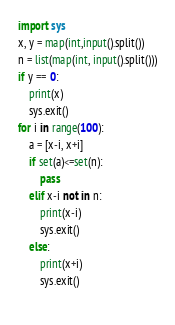<code> <loc_0><loc_0><loc_500><loc_500><_Python_>import sys
x, y = map(int,input().split())
n = list(map(int, input().split()))
if y == 0:
    print(x)
    sys.exit()
for i in range(100):
    a = [x-i, x+i]
    if set(a)<=set(n):
        pass
    elif x-i not in n:
        print(x-i)
        sys.exit()
    else:
        print(x+i)
        sys.exit()
                    </code> 